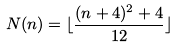Convert formula to latex. <formula><loc_0><loc_0><loc_500><loc_500>N ( n ) = \lfloor \frac { ( n + 4 ) ^ { 2 } + 4 } { 1 2 } \rfloor</formula> 